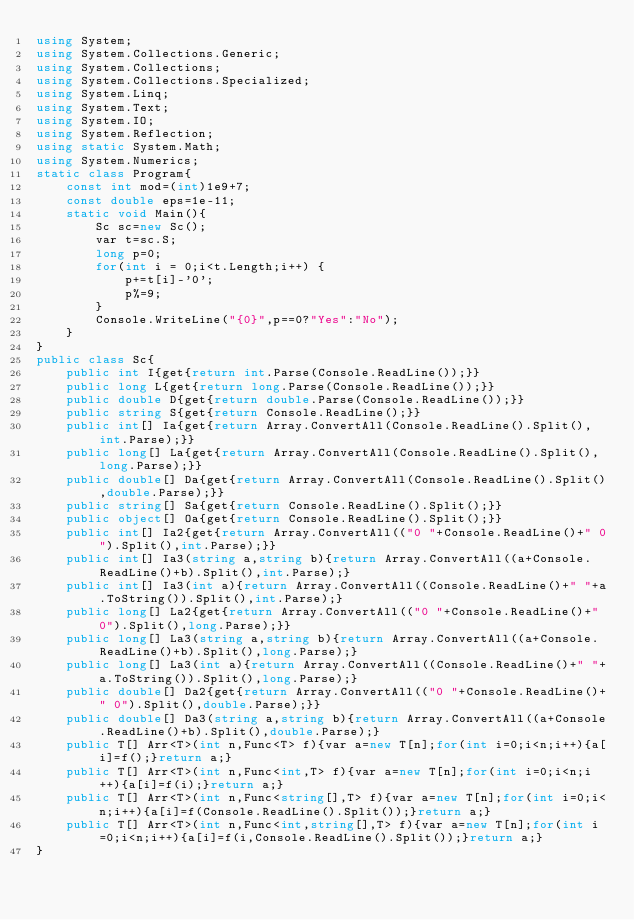<code> <loc_0><loc_0><loc_500><loc_500><_C#_>using System;
using System.Collections.Generic;
using System.Collections;
using System.Collections.Specialized;
using System.Linq;
using System.Text;
using System.IO;
using System.Reflection;
using static System.Math;
using System.Numerics;
static class Program{
	const int mod=(int)1e9+7;
	const double eps=1e-11;
	static void Main(){
		Sc sc=new Sc();
		var t=sc.S;
		long p=0;
		for(int i = 0;i<t.Length;i++) {
			p+=t[i]-'0';
			p%=9;
		}
		Console.WriteLine("{0}",p==0?"Yes":"No");
	}
}
public class Sc{
	public int I{get{return int.Parse(Console.ReadLine());}}
	public long L{get{return long.Parse(Console.ReadLine());}}
	public double D{get{return double.Parse(Console.ReadLine());}}
	public string S{get{return Console.ReadLine();}}
	public int[] Ia{get{return Array.ConvertAll(Console.ReadLine().Split(),int.Parse);}}
	public long[] La{get{return Array.ConvertAll(Console.ReadLine().Split(),long.Parse);}}
	public double[] Da{get{return Array.ConvertAll(Console.ReadLine().Split(),double.Parse);}}
	public string[] Sa{get{return Console.ReadLine().Split();}}
	public object[] Oa{get{return Console.ReadLine().Split();}}
	public int[] Ia2{get{return Array.ConvertAll(("0 "+Console.ReadLine()+" 0").Split(),int.Parse);}}
	public int[] Ia3(string a,string b){return Array.ConvertAll((a+Console.ReadLine()+b).Split(),int.Parse);}
	public int[] Ia3(int a){return Array.ConvertAll((Console.ReadLine()+" "+a.ToString()).Split(),int.Parse);}
	public long[] La2{get{return Array.ConvertAll(("0 "+Console.ReadLine()+" 0").Split(),long.Parse);}}
	public long[] La3(string a,string b){return Array.ConvertAll((a+Console.ReadLine()+b).Split(),long.Parse);}
	public long[] La3(int a){return Array.ConvertAll((Console.ReadLine()+" "+a.ToString()).Split(),long.Parse);}
	public double[] Da2{get{return Array.ConvertAll(("0 "+Console.ReadLine()+" 0").Split(),double.Parse);}}
	public double[] Da3(string a,string b){return Array.ConvertAll((a+Console.ReadLine()+b).Split(),double.Parse);}
	public T[] Arr<T>(int n,Func<T> f){var a=new T[n];for(int i=0;i<n;i++){a[i]=f();}return a;}
	public T[] Arr<T>(int n,Func<int,T> f){var a=new T[n];for(int i=0;i<n;i++){a[i]=f(i);}return a;}
	public T[] Arr<T>(int n,Func<string[],T> f){var a=new T[n];for(int i=0;i<n;i++){a[i]=f(Console.ReadLine().Split());}return a;}
	public T[] Arr<T>(int n,Func<int,string[],T> f){var a=new T[n];for(int i=0;i<n;i++){a[i]=f(i,Console.ReadLine().Split());}return a;}
}</code> 